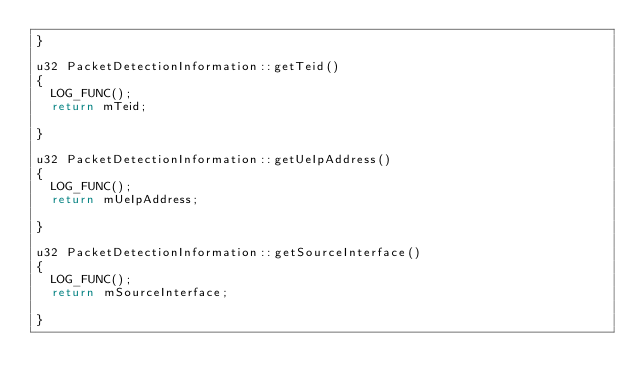<code> <loc_0><loc_0><loc_500><loc_500><_C++_>}

u32 PacketDetectionInformation::getTeid()
{
  LOG_FUNC();
  return mTeid;

}

u32 PacketDetectionInformation::getUeIpAddress()
{
  LOG_FUNC();
  return mUeIpAddress;

}

u32 PacketDetectionInformation::getSourceInterface()
{
  LOG_FUNC();
  return mSourceInterface;

}
</code> 